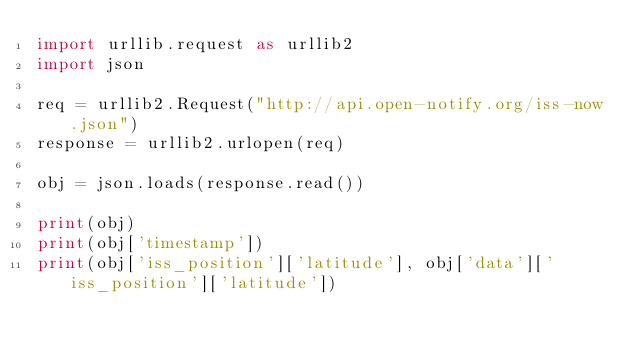Convert code to text. <code><loc_0><loc_0><loc_500><loc_500><_Python_>import urllib.request as urllib2
import json

req = urllib2.Request("http://api.open-notify.org/iss-now.json")
response = urllib2.urlopen(req)

obj = json.loads(response.read())

print(obj)
print(obj['timestamp'])
print(obj['iss_position']['latitude'], obj['data']['iss_position']['latitude'])</code> 